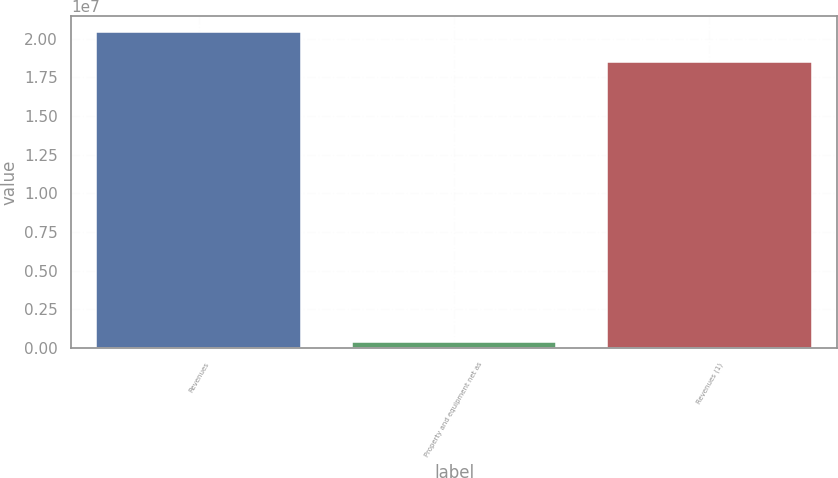<chart> <loc_0><loc_0><loc_500><loc_500><bar_chart><fcel>Revenues<fcel>Property and equipment net as<fcel>Revenues (1)<nl><fcel>2.04194e+07<fcel>395782<fcel>1.84604e+07<nl></chart> 